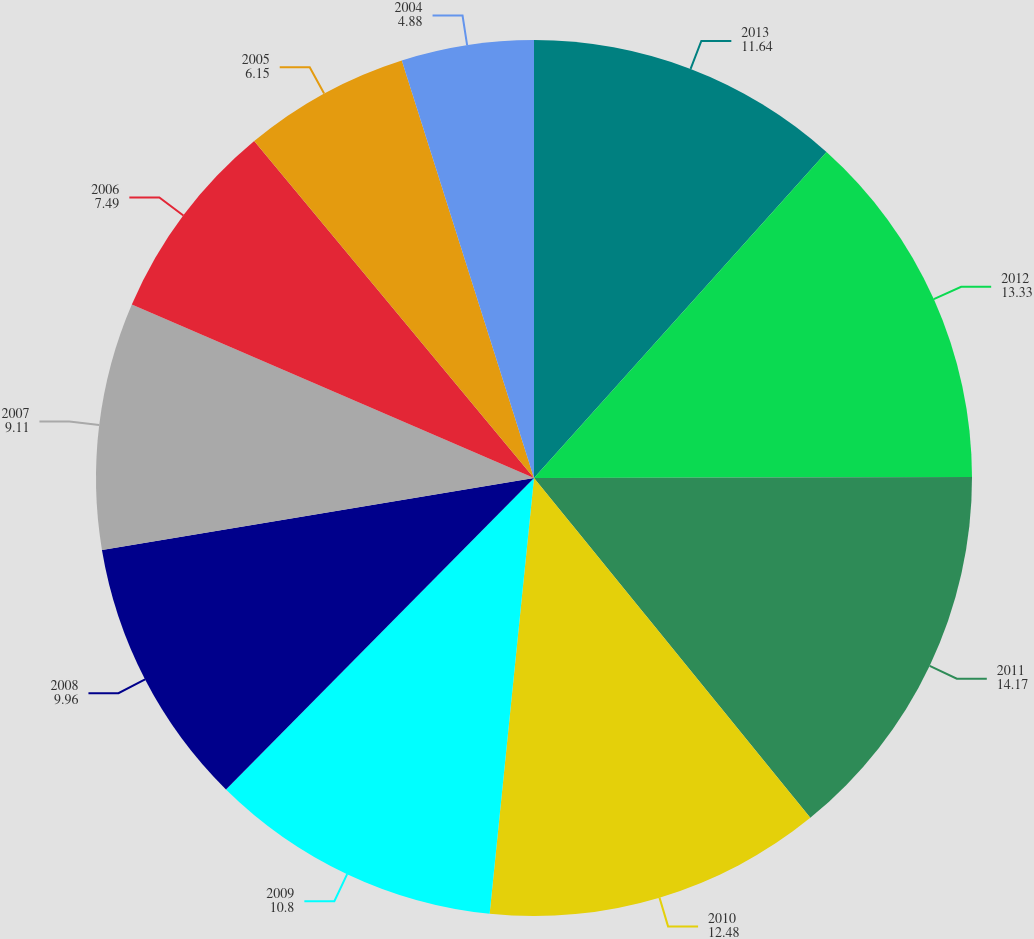Convert chart. <chart><loc_0><loc_0><loc_500><loc_500><pie_chart><fcel>2013<fcel>2012<fcel>2011<fcel>2010<fcel>2009<fcel>2008<fcel>2007<fcel>2006<fcel>2005<fcel>2004<nl><fcel>11.64%<fcel>13.33%<fcel>14.17%<fcel>12.48%<fcel>10.8%<fcel>9.96%<fcel>9.11%<fcel>7.49%<fcel>6.15%<fcel>4.88%<nl></chart> 